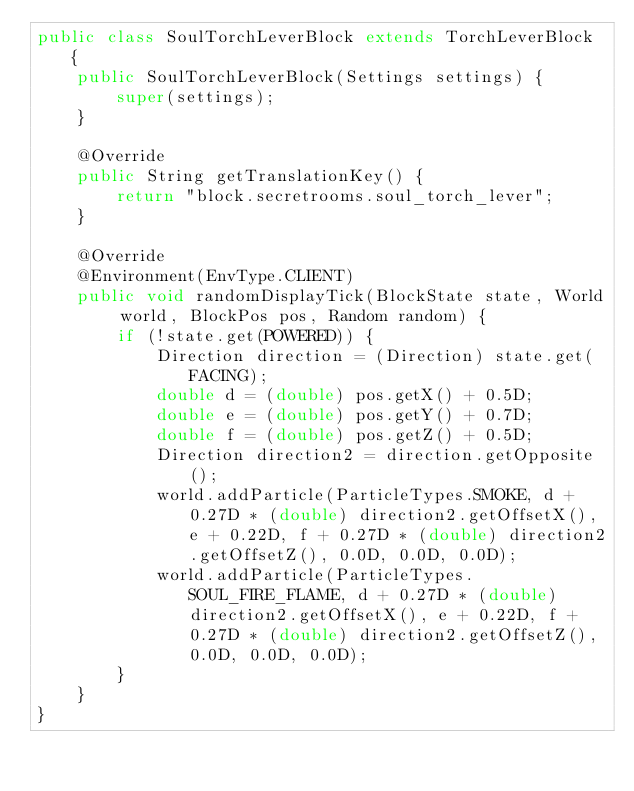Convert code to text. <code><loc_0><loc_0><loc_500><loc_500><_Java_>public class SoulTorchLeverBlock extends TorchLeverBlock {
    public SoulTorchLeverBlock(Settings settings) {
        super(settings);
    }

    @Override
    public String getTranslationKey() {
        return "block.secretrooms.soul_torch_lever";
    }

    @Override
    @Environment(EnvType.CLIENT)
    public void randomDisplayTick(BlockState state, World world, BlockPos pos, Random random) {
        if (!state.get(POWERED)) {
            Direction direction = (Direction) state.get(FACING);
            double d = (double) pos.getX() + 0.5D;
            double e = (double) pos.getY() + 0.7D;
            double f = (double) pos.getZ() + 0.5D;
            Direction direction2 = direction.getOpposite();
            world.addParticle(ParticleTypes.SMOKE, d + 0.27D * (double) direction2.getOffsetX(), e + 0.22D, f + 0.27D * (double) direction2.getOffsetZ(), 0.0D, 0.0D, 0.0D);
            world.addParticle(ParticleTypes.SOUL_FIRE_FLAME, d + 0.27D * (double) direction2.getOffsetX(), e + 0.22D, f + 0.27D * (double) direction2.getOffsetZ(), 0.0D, 0.0D, 0.0D);
        }
    }
}</code> 